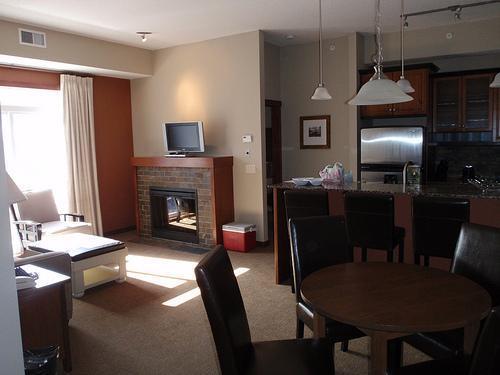How many lights can be seen in total?
Give a very brief answer. 8. How many chairs are at the breakfast bar?
Give a very brief answer. 3. 